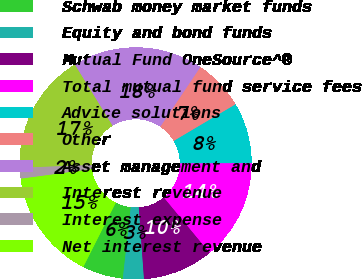<chart> <loc_0><loc_0><loc_500><loc_500><pie_chart><fcel>Schwab money market funds<fcel>Equity and bond funds<fcel>Mutual Fund OneSource^®<fcel>Total mutual fund service fees<fcel>Advice solutions<fcel>Other<fcel>Asset management and<fcel>Interest revenue<fcel>Interest expense<fcel>Net interest revenue<nl><fcel>5.69%<fcel>2.91%<fcel>9.86%<fcel>14.03%<fcel>8.47%<fcel>7.08%<fcel>18.2%<fcel>16.81%<fcel>1.52%<fcel>15.42%<nl></chart> 